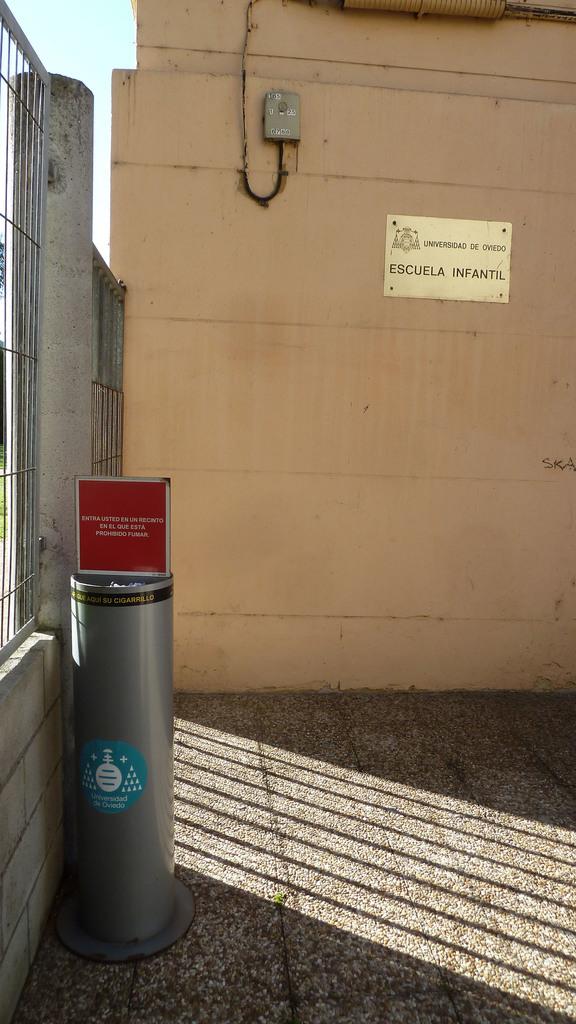Is this written in spanish?
Keep it short and to the point. Yes. What does that sign say?
Provide a succinct answer. Escuela infantil. 